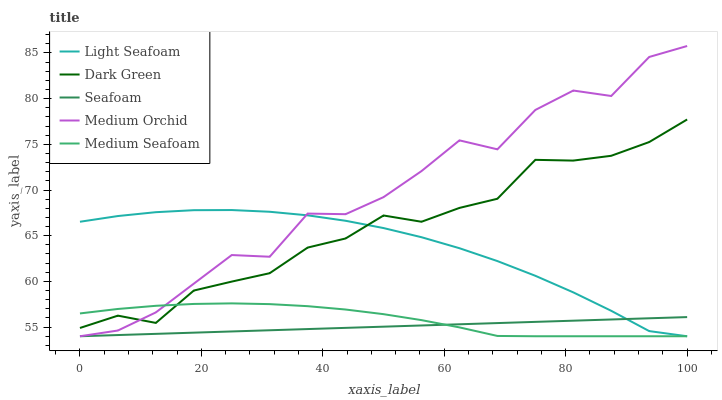Does Seafoam have the minimum area under the curve?
Answer yes or no. Yes. Does Medium Orchid have the maximum area under the curve?
Answer yes or no. Yes. Does Light Seafoam have the minimum area under the curve?
Answer yes or no. No. Does Light Seafoam have the maximum area under the curve?
Answer yes or no. No. Is Seafoam the smoothest?
Answer yes or no. Yes. Is Medium Orchid the roughest?
Answer yes or no. Yes. Is Light Seafoam the smoothest?
Answer yes or no. No. Is Light Seafoam the roughest?
Answer yes or no. No. Does Medium Orchid have the lowest value?
Answer yes or no. Yes. Does Dark Green have the lowest value?
Answer yes or no. No. Does Medium Orchid have the highest value?
Answer yes or no. Yes. Does Light Seafoam have the highest value?
Answer yes or no. No. Is Seafoam less than Dark Green?
Answer yes or no. Yes. Is Dark Green greater than Seafoam?
Answer yes or no. Yes. Does Dark Green intersect Medium Seafoam?
Answer yes or no. Yes. Is Dark Green less than Medium Seafoam?
Answer yes or no. No. Is Dark Green greater than Medium Seafoam?
Answer yes or no. No. Does Seafoam intersect Dark Green?
Answer yes or no. No. 